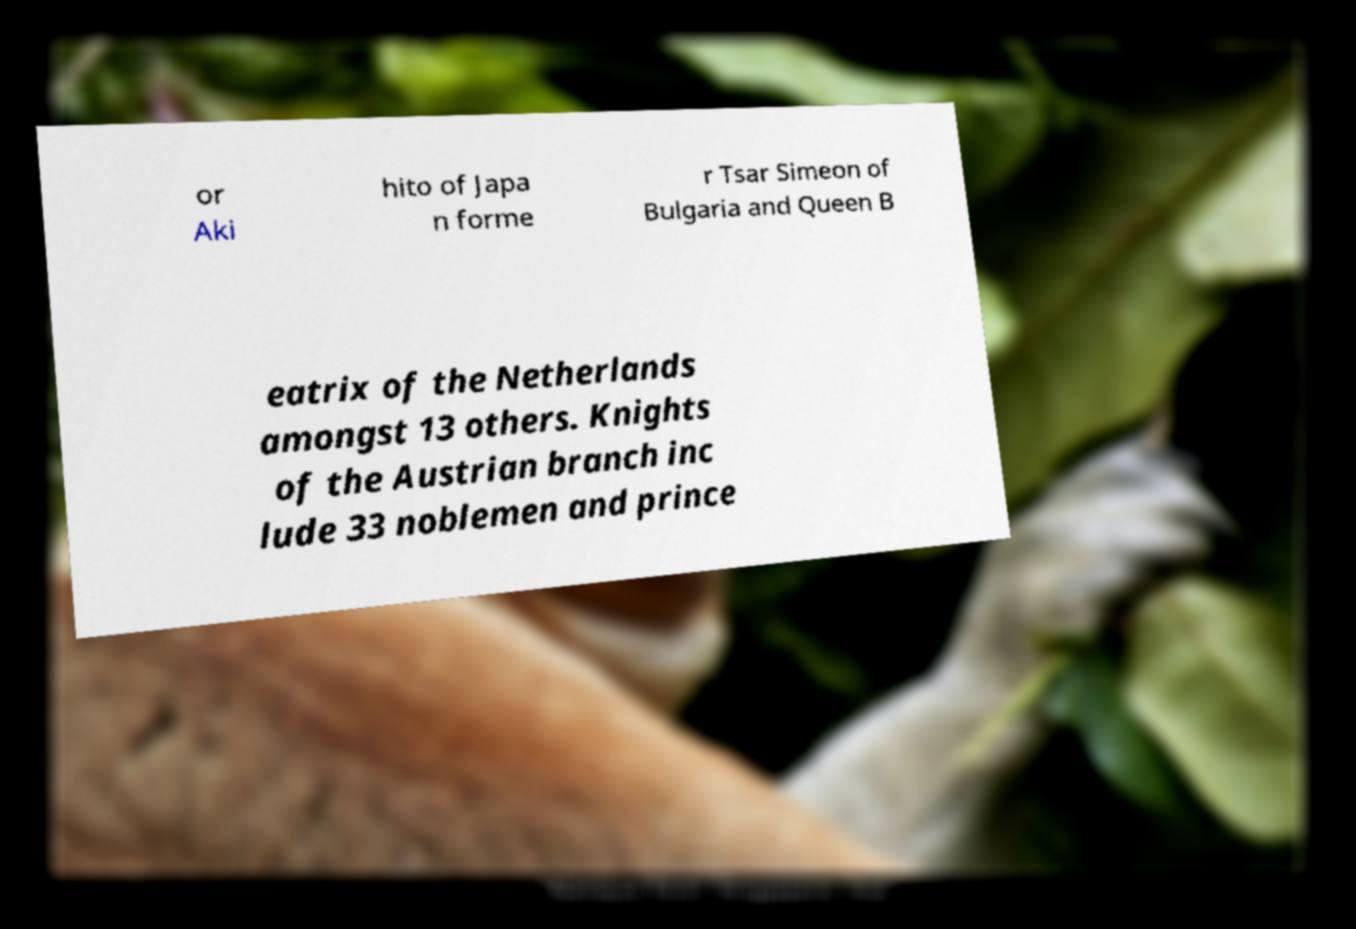Please identify and transcribe the text found in this image. or Aki hito of Japa n forme r Tsar Simeon of Bulgaria and Queen B eatrix of the Netherlands amongst 13 others. Knights of the Austrian branch inc lude 33 noblemen and prince 